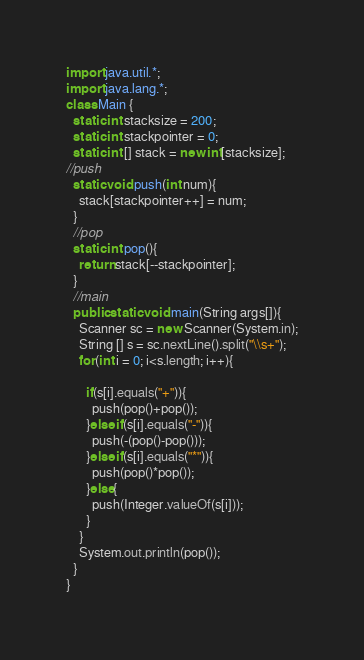Convert code to text. <code><loc_0><loc_0><loc_500><loc_500><_Java_>import java.util.*;
import java.lang.*;
class Main {
  static int stacksize = 200;
  static int stackpointer = 0;
  static int [] stack = new int[stacksize];
//push
  static void push(int num){
    stack[stackpointer++] = num;
  }
  //pop
  static int pop(){
    return stack[--stackpointer];
  }
  //main
  public static void main(String args[]){
    Scanner sc = new Scanner(System.in);
    String [] s = sc.nextLine().split("\\s+");
    for(int i = 0; i<s.length; i++){

      if(s[i].equals("+")){
        push(pop()+pop());
      }else if(s[i].equals("-")){
        push(-(pop()-pop()));
      }else if(s[i].equals("*")){
        push(pop()*pop());
      }else{
        push(Integer.valueOf(s[i]));
      }
    }
    System.out.println(pop());
  }
}
</code> 